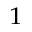Convert formula to latex. <formula><loc_0><loc_0><loc_500><loc_500>^ { 1 }</formula> 